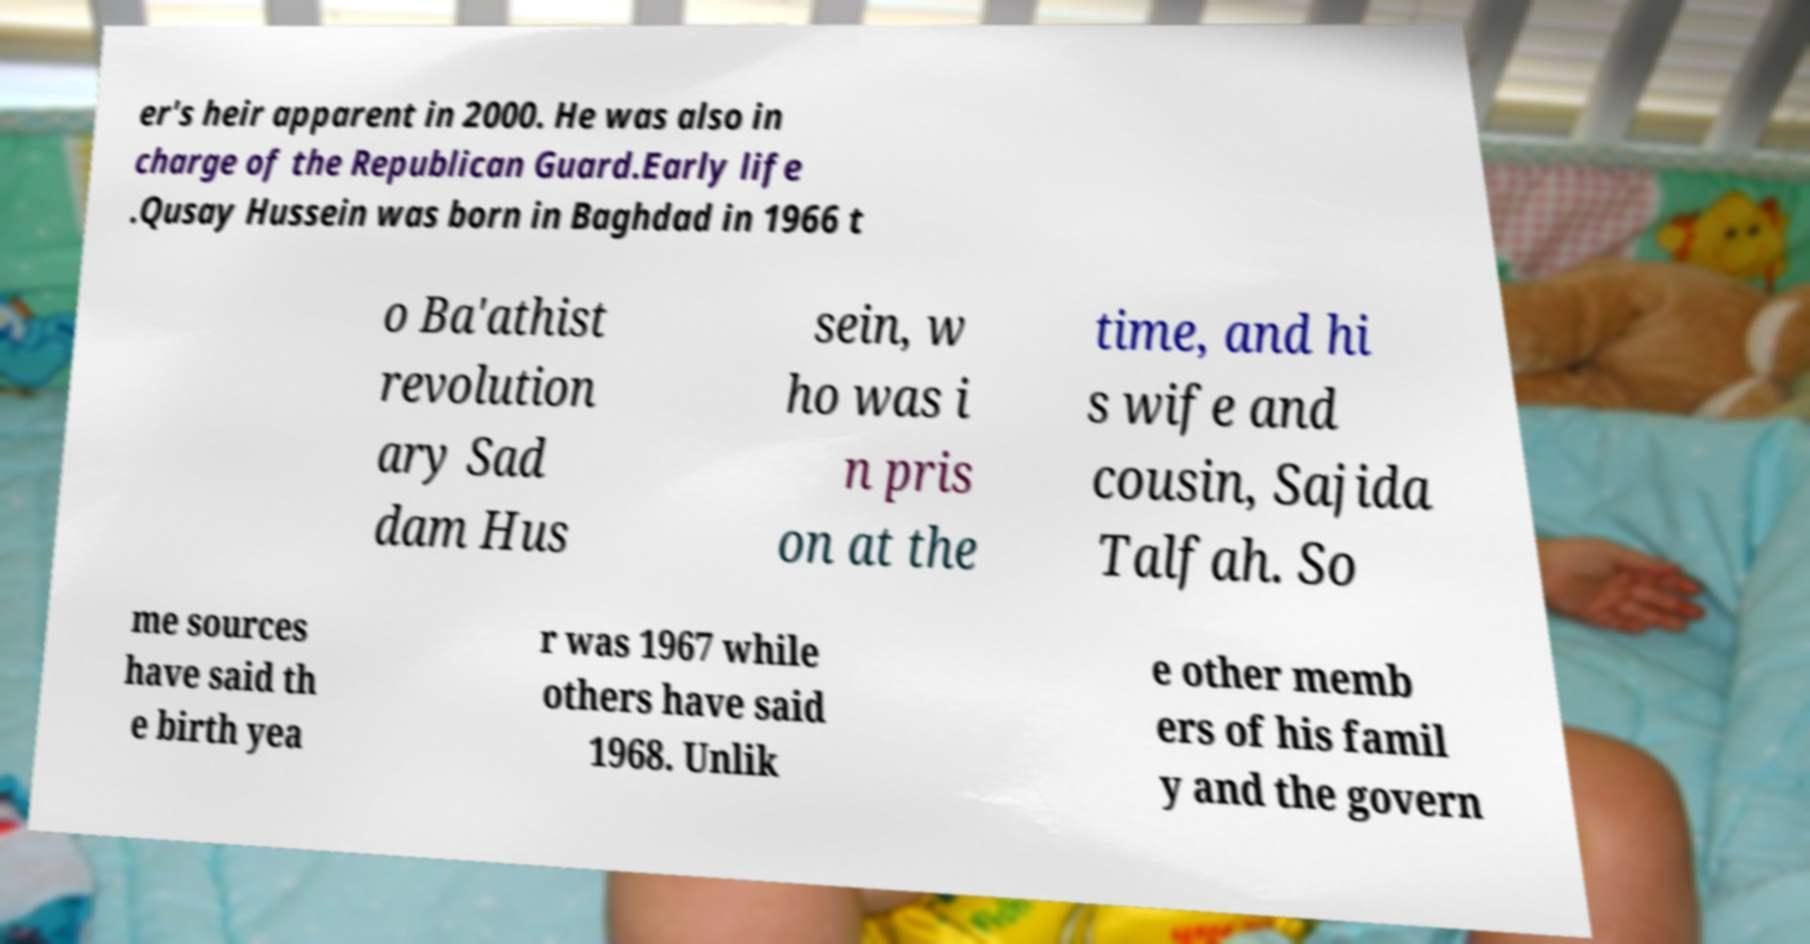For documentation purposes, I need the text within this image transcribed. Could you provide that? er's heir apparent in 2000. He was also in charge of the Republican Guard.Early life .Qusay Hussein was born in Baghdad in 1966 t o Ba'athist revolution ary Sad dam Hus sein, w ho was i n pris on at the time, and hi s wife and cousin, Sajida Talfah. So me sources have said th e birth yea r was 1967 while others have said 1968. Unlik e other memb ers of his famil y and the govern 